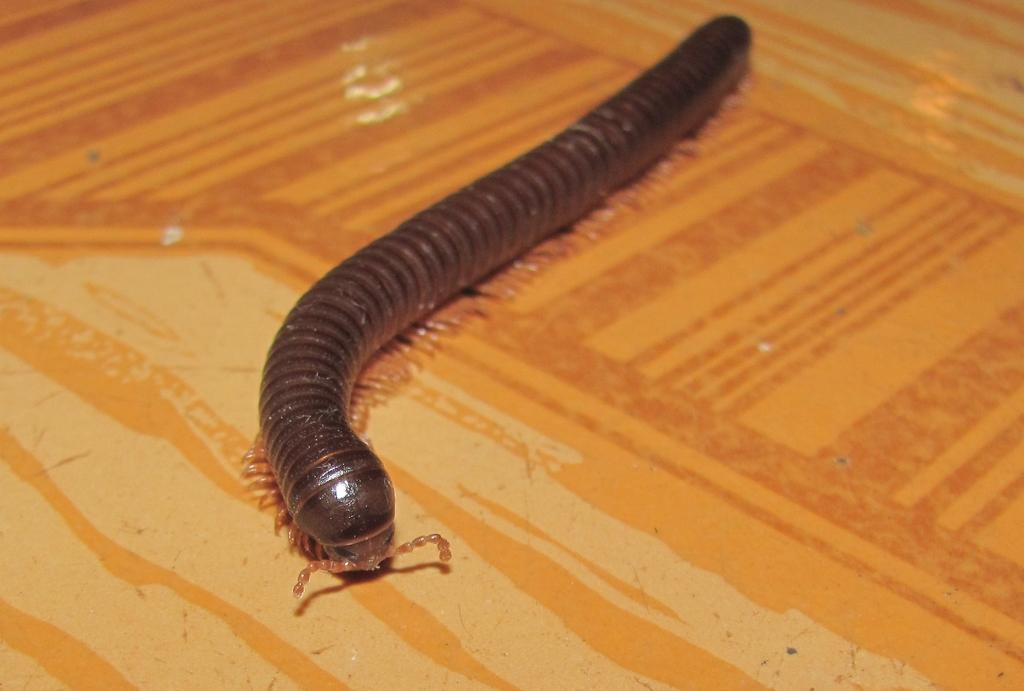What colors are present on the surface in the image? The surface in the image has orange, brown, and cream colors. What type of creature can be seen on the surface? There is an insect on the surface. What colors are present on the insect? The insect is black and brown in color. How many trucks are parked on the surface in the image? There are no trucks present in the image; it features an insect on a surface with orange, brown, and cream colors. What type of joke is being told by the insect in the image? There is no joke being told in the image; it features an insect on a surface with orange, brown, and cream colors. 